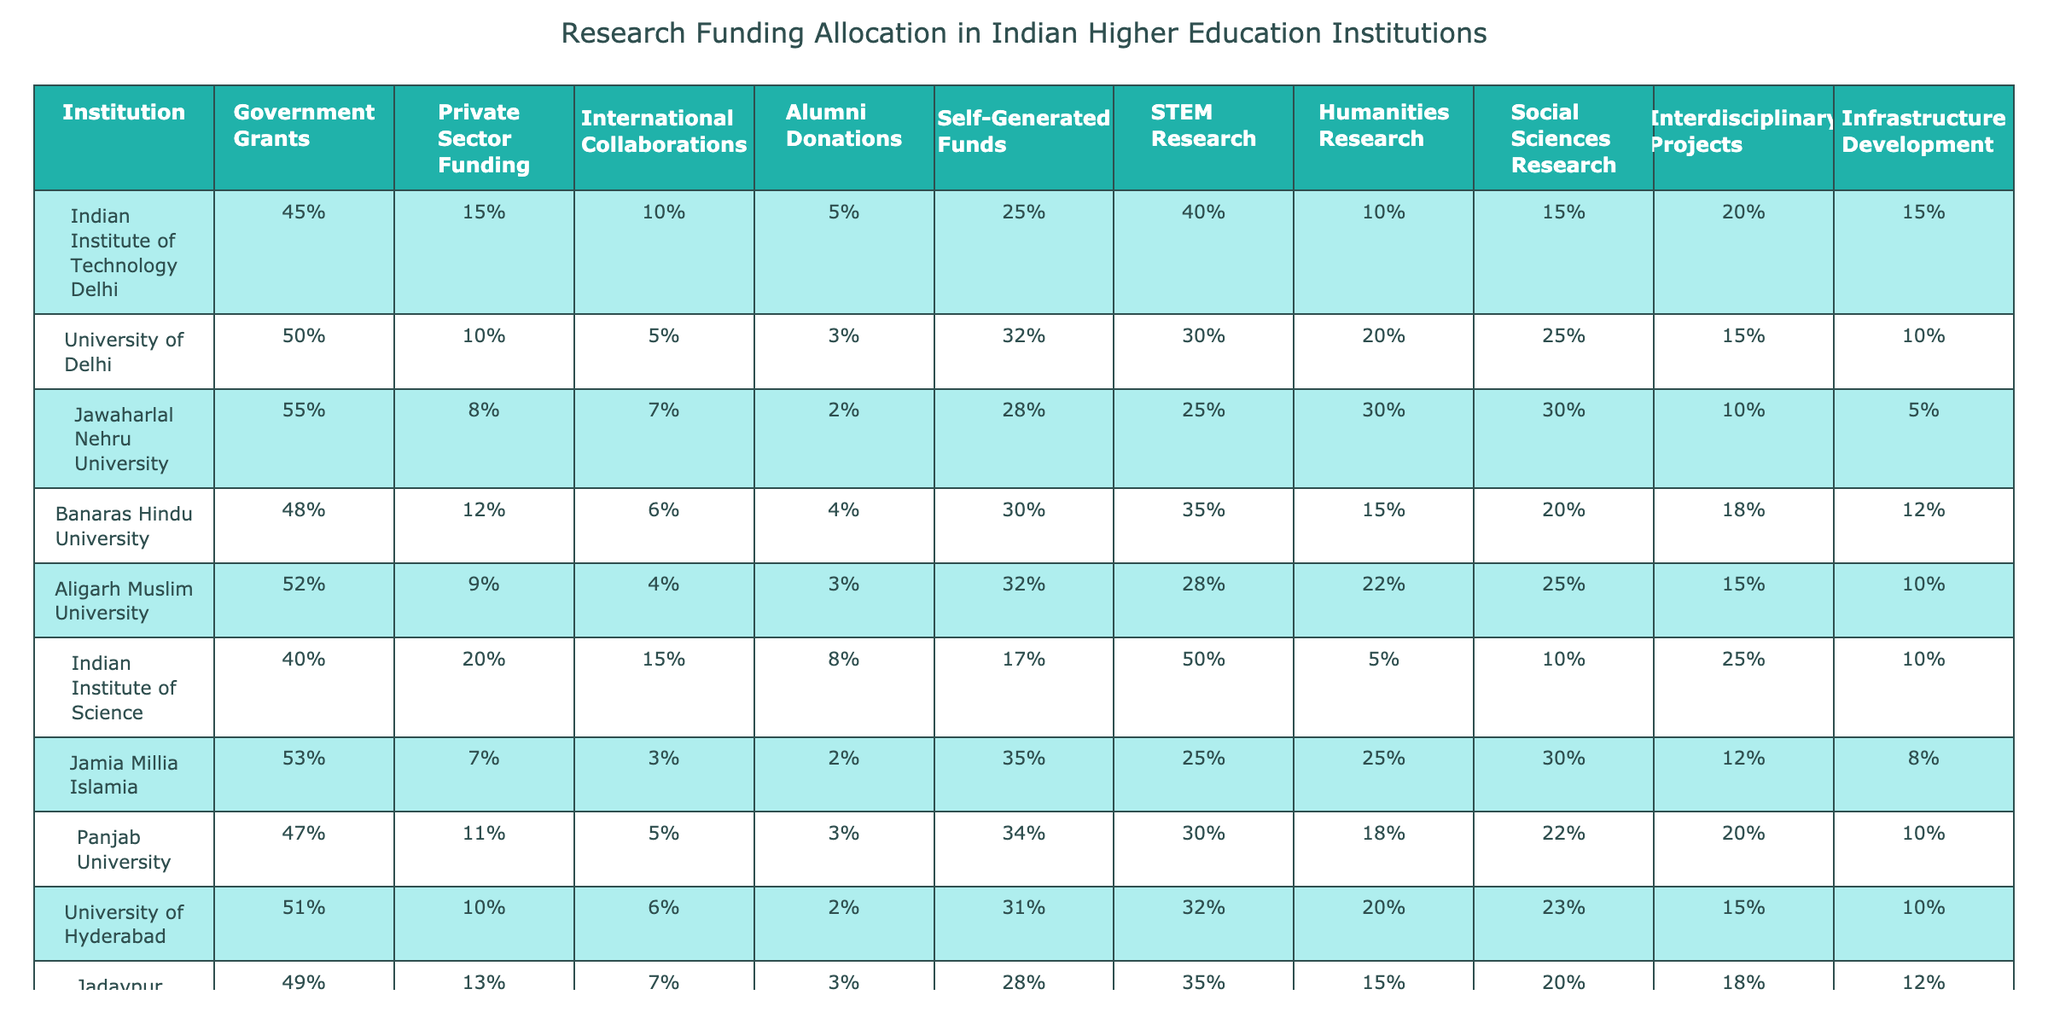What percentage of funding for the Indian Institute of Technology Delhi comes from government grants? The table shows that the Indian Institute of Technology Delhi receives 45% of its funding from government grants.
Answer: 45% Which institution has the highest percentage of private sector funding? According to the table, the Indian Institute of Science has the highest percentage of private sector funding at 20%.
Answer: 20% What is the total percentage of funding from government grants and self-generated funds for Jawaharlal Nehru University? For Jawaharlal Nehru University, government grants account for 55% and self-generated funds account for 28%. The total is 55 + 28 = 83%.
Answer: 83% True or False: The University of Delhi has more alumni donations than Jamia Millia Islamia. The table shows that the University of Delhi has 3% in alumni donations while Jamia Millia Islamia has 2%. Therefore, the statement is true.
Answer: True How does the percentage of STEM research funding at Aligarh Muslim University compare to that of the Indian Institute of Technology Delhi? Aligarh Muslim University has 28% funding for STEM research while the Indian Institute of Technology Delhi has 40%. The difference is 40 - 28 = 12%, meaning IIT Delhi has 12% more STEM research funding.
Answer: IIT Delhi has 12% more What is the average percentage of funding from international collaborations across all institutions listed? First, we sum the percentages of international collaborations: 10 + 5 + 7 + 6 + 4 + 15 + 3 + 5 + 6 + 7 = 58%. Since there are 10 institutions, we divide this sum by 10 to find the average: 58 / 10 = 5.8%.
Answer: 5.8% Which institution has the lowest percentage of infrastructure development funding? The table shows that Jawaharlal Nehru University has the lowest percentage of infrastructure development funding at 5%.
Answer: 5% What is the difference in funding for interdisciplinary projects between Banaras Hindu University and Jadavpur University? Banaras Hindu University has 18% funding for interdisciplinary projects while Jadavpur University has 20%. The difference is 20 - 18 = 2%.
Answer: 2% Is the funding from self-generated funds at the University of Hyderabad higher than that at Panjab University? The University of Hyderabad has 31% in self-generated funds while Panjab University has 34%. Therefore, the statement is false, as Panjab University has more self-generated funding.
Answer: False Which institution allocates the highest percentage of its funds to social sciences research? From the table, Jawaharlal Nehru University allocates the highest percentage to social sciences research at 30%.
Answer: 30% Calculate the total percentage of funding allocated to Humanities research across the listed institutions. Summing the percentages for Humanities research: 10 + 20 + 30 + 15 + 22 + 5 + 25 + 18 + 20 + 10 = 155%. Therefore, the total percentage is 155%.
Answer: 155% 